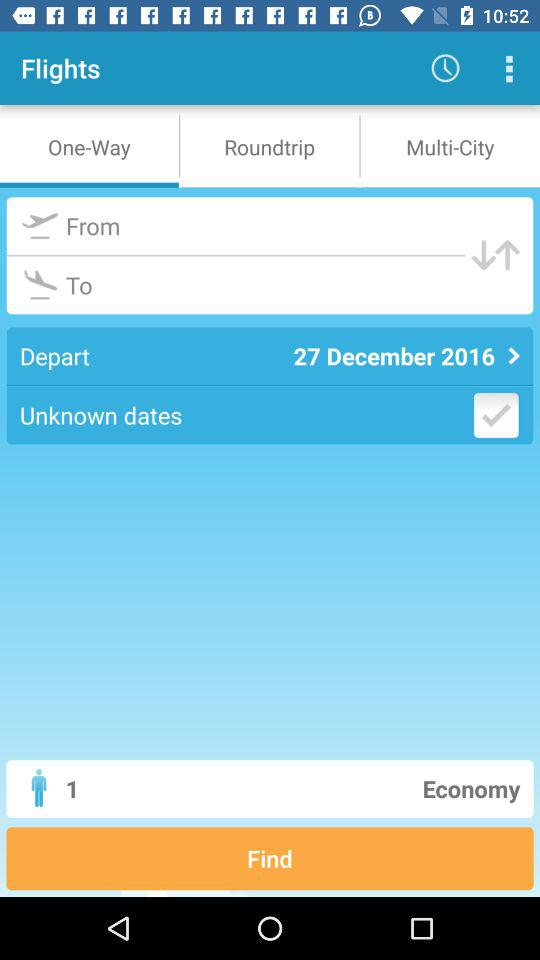Which tab are we on? You are on the "One-Way" tab. 